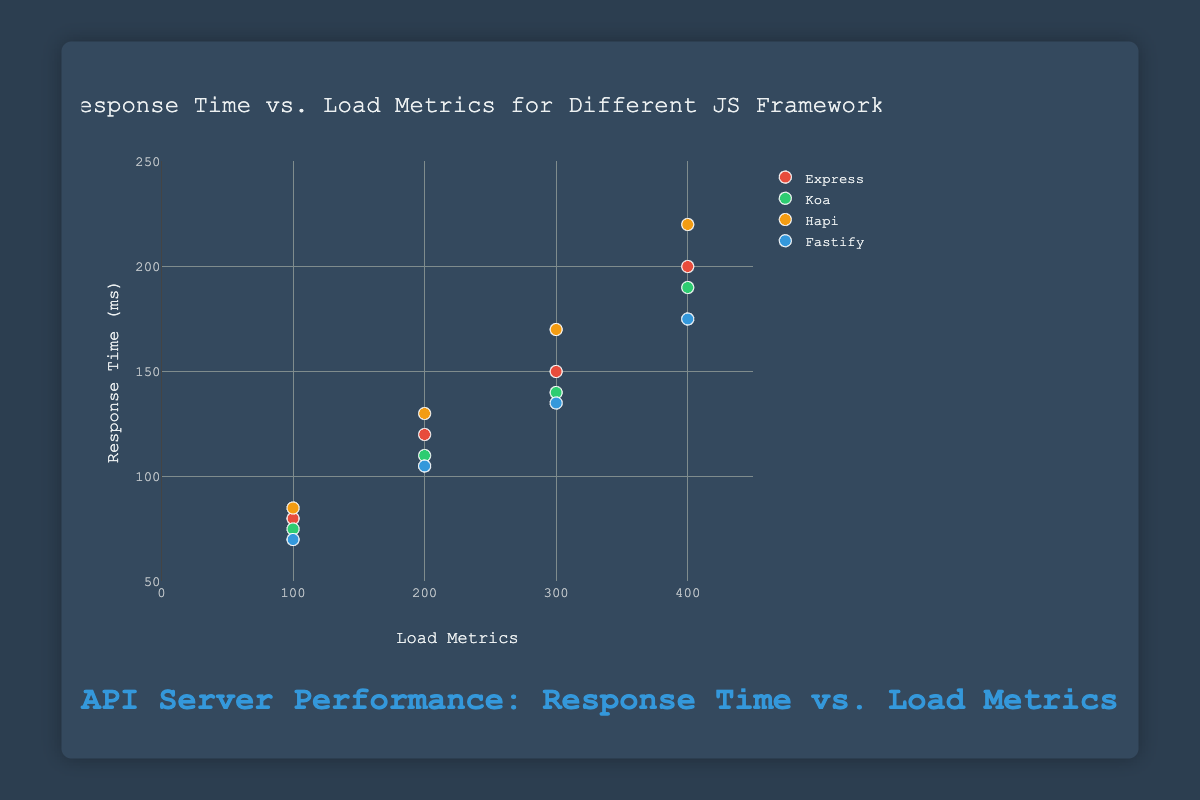What is the title of the figure? The title of the figure is displayed at the top center of the plot. It reads "Response Time vs. Load Metrics for Different JS Frameworks."
Answer: Response Time vs. Load Metrics for Different JS Frameworks How many unique JavaScript frameworks are displayed in the plot? The plot shows different colors representing different frameworks. By counting the unique legends, we can see there are four frameworks: Express, Koa, Hapi, and Fastify.
Answer: Four Which framework has the overall lowest response times? By observing the y-axis values of the response times for each framework, Fastify consistently shows the lowest response times across all load metrics.
Answer: Fastify What are the x-axis and y-axis labels? The x-axis and y-axis labels are found along the x-axis and y-axis near their respective titles. The x-axis is labeled "Load Metrics" and the y-axis is labeled "Response Time (ms)."
Answer: Load Metrics, Response Time (ms) Which framework experiences the largest increase in response time when the load metric increases from 100 to 400? The steepest slope or largest vertical rise between the points on the y-axis for each framework can be observed. Hapi shows the largest increase, from 85 ms to 220 ms.
Answer: Hapi At a load metric of 200, which framework has the longest response time? By analyzing the scatter plot, at the load metric of 200, the data points show Hapi has the longest response time of 130 ms.
Answer: Hapi How much does the response time for Express increase from a load metric of 100 to 300? The response time increase can be calculated by subtracting the response time at 100 load metrics (80 ms) from the response time at 300 load metrics (150 ms). This results in an increase of 70 ms.
Answer: 70 ms What is the response time for Koa at a load metric of 300? By checking the corresponding y-values at x=300 for Koa, the response time is directly observed as 140 ms.
Answer: 140 ms Which framework has the least variation in response times across the load metrics? By comparing the data points spread for each framework on the y-axis, Koa shows the least variation, with response times ranging from 75 ms to 190 ms.
Answer: Koa How does the maximum response time of Fastify compare to the minimum response time of Hapi? Fastify's maximum response time at 400 load metrics is 175 ms and Hapi's minimum response time at 100 load metrics is 85 ms. The difference is 175 ms - 85 ms = 90 ms. Fastify's maximum is 90 ms higher.
Answer: 90 ms higher 